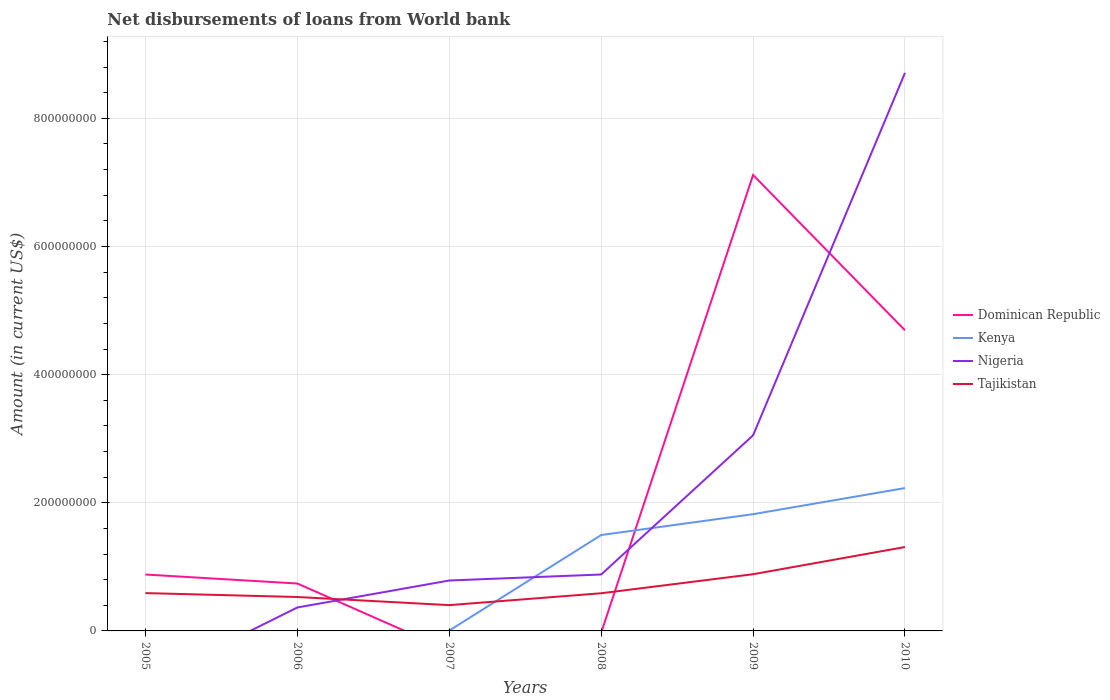How many different coloured lines are there?
Ensure brevity in your answer.  4. Is the number of lines equal to the number of legend labels?
Your answer should be very brief. No. Across all years, what is the maximum amount of loan disbursed from World Bank in Tajikistan?
Offer a very short reply. 4.03e+07. What is the total amount of loan disbursed from World Bank in Tajikistan in the graph?
Provide a succinct answer. -2.97e+07. What is the difference between the highest and the second highest amount of loan disbursed from World Bank in Dominican Republic?
Offer a terse response. 7.12e+08. What is the difference between the highest and the lowest amount of loan disbursed from World Bank in Nigeria?
Offer a very short reply. 2. How many lines are there?
Ensure brevity in your answer.  4. How many years are there in the graph?
Your answer should be compact. 6. What is the difference between two consecutive major ticks on the Y-axis?
Ensure brevity in your answer.  2.00e+08. Where does the legend appear in the graph?
Your response must be concise. Center right. How many legend labels are there?
Offer a very short reply. 4. What is the title of the graph?
Keep it short and to the point. Net disbursements of loans from World bank. What is the label or title of the X-axis?
Provide a succinct answer. Years. What is the Amount (in current US$) in Dominican Republic in 2005?
Keep it short and to the point. 8.80e+07. What is the Amount (in current US$) of Nigeria in 2005?
Make the answer very short. 0. What is the Amount (in current US$) of Tajikistan in 2005?
Your answer should be compact. 5.90e+07. What is the Amount (in current US$) of Dominican Republic in 2006?
Provide a succinct answer. 7.40e+07. What is the Amount (in current US$) in Kenya in 2006?
Your answer should be very brief. 0. What is the Amount (in current US$) in Nigeria in 2006?
Offer a terse response. 3.66e+07. What is the Amount (in current US$) of Tajikistan in 2006?
Give a very brief answer. 5.29e+07. What is the Amount (in current US$) in Dominican Republic in 2007?
Provide a succinct answer. 0. What is the Amount (in current US$) in Kenya in 2007?
Ensure brevity in your answer.  5.68e+05. What is the Amount (in current US$) in Nigeria in 2007?
Make the answer very short. 7.87e+07. What is the Amount (in current US$) in Tajikistan in 2007?
Your answer should be very brief. 4.03e+07. What is the Amount (in current US$) in Kenya in 2008?
Make the answer very short. 1.50e+08. What is the Amount (in current US$) in Nigeria in 2008?
Your answer should be very brief. 8.80e+07. What is the Amount (in current US$) in Tajikistan in 2008?
Keep it short and to the point. 5.88e+07. What is the Amount (in current US$) in Dominican Republic in 2009?
Keep it short and to the point. 7.12e+08. What is the Amount (in current US$) in Kenya in 2009?
Your answer should be compact. 1.82e+08. What is the Amount (in current US$) of Nigeria in 2009?
Your answer should be very brief. 3.05e+08. What is the Amount (in current US$) of Tajikistan in 2009?
Provide a short and direct response. 8.85e+07. What is the Amount (in current US$) in Dominican Republic in 2010?
Your answer should be compact. 4.69e+08. What is the Amount (in current US$) of Kenya in 2010?
Make the answer very short. 2.23e+08. What is the Amount (in current US$) in Nigeria in 2010?
Your answer should be compact. 8.71e+08. What is the Amount (in current US$) of Tajikistan in 2010?
Keep it short and to the point. 1.31e+08. Across all years, what is the maximum Amount (in current US$) in Dominican Republic?
Give a very brief answer. 7.12e+08. Across all years, what is the maximum Amount (in current US$) of Kenya?
Offer a very short reply. 2.23e+08. Across all years, what is the maximum Amount (in current US$) in Nigeria?
Provide a succinct answer. 8.71e+08. Across all years, what is the maximum Amount (in current US$) of Tajikistan?
Your answer should be compact. 1.31e+08. Across all years, what is the minimum Amount (in current US$) of Dominican Republic?
Your answer should be compact. 0. Across all years, what is the minimum Amount (in current US$) in Nigeria?
Ensure brevity in your answer.  0. Across all years, what is the minimum Amount (in current US$) of Tajikistan?
Ensure brevity in your answer.  4.03e+07. What is the total Amount (in current US$) of Dominican Republic in the graph?
Offer a terse response. 1.34e+09. What is the total Amount (in current US$) in Kenya in the graph?
Your answer should be very brief. 5.55e+08. What is the total Amount (in current US$) in Nigeria in the graph?
Provide a short and direct response. 1.38e+09. What is the total Amount (in current US$) in Tajikistan in the graph?
Provide a succinct answer. 4.30e+08. What is the difference between the Amount (in current US$) in Dominican Republic in 2005 and that in 2006?
Keep it short and to the point. 1.40e+07. What is the difference between the Amount (in current US$) in Tajikistan in 2005 and that in 2006?
Provide a short and direct response. 6.09e+06. What is the difference between the Amount (in current US$) of Tajikistan in 2005 and that in 2007?
Give a very brief answer. 1.88e+07. What is the difference between the Amount (in current US$) of Tajikistan in 2005 and that in 2008?
Ensure brevity in your answer.  2.54e+05. What is the difference between the Amount (in current US$) in Dominican Republic in 2005 and that in 2009?
Give a very brief answer. -6.24e+08. What is the difference between the Amount (in current US$) in Tajikistan in 2005 and that in 2009?
Provide a succinct answer. -2.95e+07. What is the difference between the Amount (in current US$) of Dominican Republic in 2005 and that in 2010?
Ensure brevity in your answer.  -3.81e+08. What is the difference between the Amount (in current US$) in Tajikistan in 2005 and that in 2010?
Make the answer very short. -7.19e+07. What is the difference between the Amount (in current US$) in Nigeria in 2006 and that in 2007?
Your answer should be compact. -4.21e+07. What is the difference between the Amount (in current US$) in Tajikistan in 2006 and that in 2007?
Provide a succinct answer. 1.27e+07. What is the difference between the Amount (in current US$) of Nigeria in 2006 and that in 2008?
Provide a succinct answer. -5.14e+07. What is the difference between the Amount (in current US$) in Tajikistan in 2006 and that in 2008?
Offer a terse response. -5.84e+06. What is the difference between the Amount (in current US$) in Dominican Republic in 2006 and that in 2009?
Offer a terse response. -6.38e+08. What is the difference between the Amount (in current US$) in Nigeria in 2006 and that in 2009?
Your answer should be compact. -2.69e+08. What is the difference between the Amount (in current US$) in Tajikistan in 2006 and that in 2009?
Give a very brief answer. -3.56e+07. What is the difference between the Amount (in current US$) in Dominican Republic in 2006 and that in 2010?
Provide a succinct answer. -3.95e+08. What is the difference between the Amount (in current US$) in Nigeria in 2006 and that in 2010?
Keep it short and to the point. -8.34e+08. What is the difference between the Amount (in current US$) of Tajikistan in 2006 and that in 2010?
Provide a short and direct response. -7.80e+07. What is the difference between the Amount (in current US$) in Kenya in 2007 and that in 2008?
Your response must be concise. -1.49e+08. What is the difference between the Amount (in current US$) in Nigeria in 2007 and that in 2008?
Ensure brevity in your answer.  -9.36e+06. What is the difference between the Amount (in current US$) of Tajikistan in 2007 and that in 2008?
Provide a succinct answer. -1.85e+07. What is the difference between the Amount (in current US$) of Kenya in 2007 and that in 2009?
Provide a short and direct response. -1.82e+08. What is the difference between the Amount (in current US$) in Nigeria in 2007 and that in 2009?
Your answer should be very brief. -2.27e+08. What is the difference between the Amount (in current US$) in Tajikistan in 2007 and that in 2009?
Provide a short and direct response. -4.82e+07. What is the difference between the Amount (in current US$) of Kenya in 2007 and that in 2010?
Provide a short and direct response. -2.22e+08. What is the difference between the Amount (in current US$) of Nigeria in 2007 and that in 2010?
Keep it short and to the point. -7.92e+08. What is the difference between the Amount (in current US$) of Tajikistan in 2007 and that in 2010?
Offer a terse response. -9.07e+07. What is the difference between the Amount (in current US$) in Kenya in 2008 and that in 2009?
Your answer should be compact. -3.25e+07. What is the difference between the Amount (in current US$) of Nigeria in 2008 and that in 2009?
Your response must be concise. -2.17e+08. What is the difference between the Amount (in current US$) in Tajikistan in 2008 and that in 2009?
Your answer should be very brief. -2.97e+07. What is the difference between the Amount (in current US$) in Kenya in 2008 and that in 2010?
Provide a short and direct response. -7.33e+07. What is the difference between the Amount (in current US$) of Nigeria in 2008 and that in 2010?
Ensure brevity in your answer.  -7.83e+08. What is the difference between the Amount (in current US$) of Tajikistan in 2008 and that in 2010?
Make the answer very short. -7.22e+07. What is the difference between the Amount (in current US$) in Dominican Republic in 2009 and that in 2010?
Provide a succinct answer. 2.42e+08. What is the difference between the Amount (in current US$) of Kenya in 2009 and that in 2010?
Offer a terse response. -4.08e+07. What is the difference between the Amount (in current US$) of Nigeria in 2009 and that in 2010?
Your answer should be very brief. -5.66e+08. What is the difference between the Amount (in current US$) of Tajikistan in 2009 and that in 2010?
Your response must be concise. -4.24e+07. What is the difference between the Amount (in current US$) in Dominican Republic in 2005 and the Amount (in current US$) in Nigeria in 2006?
Offer a terse response. 5.14e+07. What is the difference between the Amount (in current US$) of Dominican Republic in 2005 and the Amount (in current US$) of Tajikistan in 2006?
Offer a very short reply. 3.51e+07. What is the difference between the Amount (in current US$) of Dominican Republic in 2005 and the Amount (in current US$) of Kenya in 2007?
Offer a terse response. 8.74e+07. What is the difference between the Amount (in current US$) in Dominican Republic in 2005 and the Amount (in current US$) in Nigeria in 2007?
Offer a very short reply. 9.33e+06. What is the difference between the Amount (in current US$) in Dominican Republic in 2005 and the Amount (in current US$) in Tajikistan in 2007?
Your answer should be very brief. 4.77e+07. What is the difference between the Amount (in current US$) in Dominican Republic in 2005 and the Amount (in current US$) in Kenya in 2008?
Offer a very short reply. -6.17e+07. What is the difference between the Amount (in current US$) of Dominican Republic in 2005 and the Amount (in current US$) of Nigeria in 2008?
Make the answer very short. -3.40e+04. What is the difference between the Amount (in current US$) of Dominican Republic in 2005 and the Amount (in current US$) of Tajikistan in 2008?
Offer a very short reply. 2.92e+07. What is the difference between the Amount (in current US$) in Dominican Republic in 2005 and the Amount (in current US$) in Kenya in 2009?
Keep it short and to the point. -9.42e+07. What is the difference between the Amount (in current US$) of Dominican Republic in 2005 and the Amount (in current US$) of Nigeria in 2009?
Provide a short and direct response. -2.17e+08. What is the difference between the Amount (in current US$) of Dominican Republic in 2005 and the Amount (in current US$) of Tajikistan in 2009?
Ensure brevity in your answer.  -4.91e+05. What is the difference between the Amount (in current US$) in Dominican Republic in 2005 and the Amount (in current US$) in Kenya in 2010?
Your response must be concise. -1.35e+08. What is the difference between the Amount (in current US$) of Dominican Republic in 2005 and the Amount (in current US$) of Nigeria in 2010?
Offer a terse response. -7.83e+08. What is the difference between the Amount (in current US$) in Dominican Republic in 2005 and the Amount (in current US$) in Tajikistan in 2010?
Ensure brevity in your answer.  -4.29e+07. What is the difference between the Amount (in current US$) in Dominican Republic in 2006 and the Amount (in current US$) in Kenya in 2007?
Make the answer very short. 7.34e+07. What is the difference between the Amount (in current US$) of Dominican Republic in 2006 and the Amount (in current US$) of Nigeria in 2007?
Your answer should be very brief. -4.69e+06. What is the difference between the Amount (in current US$) in Dominican Republic in 2006 and the Amount (in current US$) in Tajikistan in 2007?
Ensure brevity in your answer.  3.37e+07. What is the difference between the Amount (in current US$) in Nigeria in 2006 and the Amount (in current US$) in Tajikistan in 2007?
Keep it short and to the point. -3.66e+06. What is the difference between the Amount (in current US$) in Dominican Republic in 2006 and the Amount (in current US$) in Kenya in 2008?
Keep it short and to the point. -7.57e+07. What is the difference between the Amount (in current US$) of Dominican Republic in 2006 and the Amount (in current US$) of Nigeria in 2008?
Make the answer very short. -1.41e+07. What is the difference between the Amount (in current US$) of Dominican Republic in 2006 and the Amount (in current US$) of Tajikistan in 2008?
Your answer should be very brief. 1.52e+07. What is the difference between the Amount (in current US$) in Nigeria in 2006 and the Amount (in current US$) in Tajikistan in 2008?
Give a very brief answer. -2.22e+07. What is the difference between the Amount (in current US$) of Dominican Republic in 2006 and the Amount (in current US$) of Kenya in 2009?
Keep it short and to the point. -1.08e+08. What is the difference between the Amount (in current US$) of Dominican Republic in 2006 and the Amount (in current US$) of Nigeria in 2009?
Your answer should be compact. -2.31e+08. What is the difference between the Amount (in current US$) in Dominican Republic in 2006 and the Amount (in current US$) in Tajikistan in 2009?
Offer a very short reply. -1.45e+07. What is the difference between the Amount (in current US$) of Nigeria in 2006 and the Amount (in current US$) of Tajikistan in 2009?
Give a very brief answer. -5.19e+07. What is the difference between the Amount (in current US$) in Dominican Republic in 2006 and the Amount (in current US$) in Kenya in 2010?
Offer a terse response. -1.49e+08. What is the difference between the Amount (in current US$) in Dominican Republic in 2006 and the Amount (in current US$) in Nigeria in 2010?
Your answer should be very brief. -7.97e+08. What is the difference between the Amount (in current US$) of Dominican Republic in 2006 and the Amount (in current US$) of Tajikistan in 2010?
Make the answer very short. -5.69e+07. What is the difference between the Amount (in current US$) in Nigeria in 2006 and the Amount (in current US$) in Tajikistan in 2010?
Offer a terse response. -9.43e+07. What is the difference between the Amount (in current US$) in Kenya in 2007 and the Amount (in current US$) in Nigeria in 2008?
Keep it short and to the point. -8.75e+07. What is the difference between the Amount (in current US$) of Kenya in 2007 and the Amount (in current US$) of Tajikistan in 2008?
Provide a short and direct response. -5.82e+07. What is the difference between the Amount (in current US$) of Nigeria in 2007 and the Amount (in current US$) of Tajikistan in 2008?
Make the answer very short. 1.99e+07. What is the difference between the Amount (in current US$) of Kenya in 2007 and the Amount (in current US$) of Nigeria in 2009?
Give a very brief answer. -3.05e+08. What is the difference between the Amount (in current US$) in Kenya in 2007 and the Amount (in current US$) in Tajikistan in 2009?
Provide a short and direct response. -8.79e+07. What is the difference between the Amount (in current US$) in Nigeria in 2007 and the Amount (in current US$) in Tajikistan in 2009?
Give a very brief answer. -9.82e+06. What is the difference between the Amount (in current US$) of Kenya in 2007 and the Amount (in current US$) of Nigeria in 2010?
Keep it short and to the point. -8.70e+08. What is the difference between the Amount (in current US$) in Kenya in 2007 and the Amount (in current US$) in Tajikistan in 2010?
Give a very brief answer. -1.30e+08. What is the difference between the Amount (in current US$) of Nigeria in 2007 and the Amount (in current US$) of Tajikistan in 2010?
Give a very brief answer. -5.23e+07. What is the difference between the Amount (in current US$) of Kenya in 2008 and the Amount (in current US$) of Nigeria in 2009?
Your answer should be compact. -1.56e+08. What is the difference between the Amount (in current US$) of Kenya in 2008 and the Amount (in current US$) of Tajikistan in 2009?
Offer a very short reply. 6.12e+07. What is the difference between the Amount (in current US$) in Nigeria in 2008 and the Amount (in current US$) in Tajikistan in 2009?
Make the answer very short. -4.57e+05. What is the difference between the Amount (in current US$) of Kenya in 2008 and the Amount (in current US$) of Nigeria in 2010?
Your answer should be compact. -7.21e+08. What is the difference between the Amount (in current US$) in Kenya in 2008 and the Amount (in current US$) in Tajikistan in 2010?
Offer a terse response. 1.87e+07. What is the difference between the Amount (in current US$) of Nigeria in 2008 and the Amount (in current US$) of Tajikistan in 2010?
Provide a succinct answer. -4.29e+07. What is the difference between the Amount (in current US$) in Dominican Republic in 2009 and the Amount (in current US$) in Kenya in 2010?
Ensure brevity in your answer.  4.89e+08. What is the difference between the Amount (in current US$) in Dominican Republic in 2009 and the Amount (in current US$) in Nigeria in 2010?
Your response must be concise. -1.59e+08. What is the difference between the Amount (in current US$) in Dominican Republic in 2009 and the Amount (in current US$) in Tajikistan in 2010?
Make the answer very short. 5.81e+08. What is the difference between the Amount (in current US$) in Kenya in 2009 and the Amount (in current US$) in Nigeria in 2010?
Your answer should be very brief. -6.89e+08. What is the difference between the Amount (in current US$) in Kenya in 2009 and the Amount (in current US$) in Tajikistan in 2010?
Keep it short and to the point. 5.12e+07. What is the difference between the Amount (in current US$) of Nigeria in 2009 and the Amount (in current US$) of Tajikistan in 2010?
Give a very brief answer. 1.74e+08. What is the average Amount (in current US$) of Dominican Republic per year?
Your response must be concise. 2.24e+08. What is the average Amount (in current US$) in Kenya per year?
Keep it short and to the point. 9.26e+07. What is the average Amount (in current US$) in Nigeria per year?
Your answer should be very brief. 2.30e+08. What is the average Amount (in current US$) in Tajikistan per year?
Your answer should be very brief. 7.17e+07. In the year 2005, what is the difference between the Amount (in current US$) in Dominican Republic and Amount (in current US$) in Tajikistan?
Keep it short and to the point. 2.90e+07. In the year 2006, what is the difference between the Amount (in current US$) of Dominican Republic and Amount (in current US$) of Nigeria?
Ensure brevity in your answer.  3.74e+07. In the year 2006, what is the difference between the Amount (in current US$) in Dominican Republic and Amount (in current US$) in Tajikistan?
Your response must be concise. 2.11e+07. In the year 2006, what is the difference between the Amount (in current US$) in Nigeria and Amount (in current US$) in Tajikistan?
Keep it short and to the point. -1.63e+07. In the year 2007, what is the difference between the Amount (in current US$) of Kenya and Amount (in current US$) of Nigeria?
Offer a terse response. -7.81e+07. In the year 2007, what is the difference between the Amount (in current US$) in Kenya and Amount (in current US$) in Tajikistan?
Ensure brevity in your answer.  -3.97e+07. In the year 2007, what is the difference between the Amount (in current US$) in Nigeria and Amount (in current US$) in Tajikistan?
Your answer should be compact. 3.84e+07. In the year 2008, what is the difference between the Amount (in current US$) of Kenya and Amount (in current US$) of Nigeria?
Provide a short and direct response. 6.16e+07. In the year 2008, what is the difference between the Amount (in current US$) of Kenya and Amount (in current US$) of Tajikistan?
Your response must be concise. 9.09e+07. In the year 2008, what is the difference between the Amount (in current US$) in Nigeria and Amount (in current US$) in Tajikistan?
Offer a very short reply. 2.93e+07. In the year 2009, what is the difference between the Amount (in current US$) in Dominican Republic and Amount (in current US$) in Kenya?
Offer a very short reply. 5.29e+08. In the year 2009, what is the difference between the Amount (in current US$) in Dominican Republic and Amount (in current US$) in Nigeria?
Make the answer very short. 4.06e+08. In the year 2009, what is the difference between the Amount (in current US$) of Dominican Republic and Amount (in current US$) of Tajikistan?
Offer a very short reply. 6.23e+08. In the year 2009, what is the difference between the Amount (in current US$) in Kenya and Amount (in current US$) in Nigeria?
Make the answer very short. -1.23e+08. In the year 2009, what is the difference between the Amount (in current US$) of Kenya and Amount (in current US$) of Tajikistan?
Your answer should be compact. 9.37e+07. In the year 2009, what is the difference between the Amount (in current US$) in Nigeria and Amount (in current US$) in Tajikistan?
Provide a succinct answer. 2.17e+08. In the year 2010, what is the difference between the Amount (in current US$) of Dominican Republic and Amount (in current US$) of Kenya?
Ensure brevity in your answer.  2.46e+08. In the year 2010, what is the difference between the Amount (in current US$) of Dominican Republic and Amount (in current US$) of Nigeria?
Offer a terse response. -4.02e+08. In the year 2010, what is the difference between the Amount (in current US$) of Dominican Republic and Amount (in current US$) of Tajikistan?
Keep it short and to the point. 3.38e+08. In the year 2010, what is the difference between the Amount (in current US$) in Kenya and Amount (in current US$) in Nigeria?
Provide a short and direct response. -6.48e+08. In the year 2010, what is the difference between the Amount (in current US$) in Kenya and Amount (in current US$) in Tajikistan?
Offer a very short reply. 9.20e+07. In the year 2010, what is the difference between the Amount (in current US$) of Nigeria and Amount (in current US$) of Tajikistan?
Ensure brevity in your answer.  7.40e+08. What is the ratio of the Amount (in current US$) of Dominican Republic in 2005 to that in 2006?
Offer a terse response. 1.19. What is the ratio of the Amount (in current US$) of Tajikistan in 2005 to that in 2006?
Your answer should be very brief. 1.11. What is the ratio of the Amount (in current US$) in Tajikistan in 2005 to that in 2007?
Provide a short and direct response. 1.47. What is the ratio of the Amount (in current US$) of Dominican Republic in 2005 to that in 2009?
Ensure brevity in your answer.  0.12. What is the ratio of the Amount (in current US$) in Tajikistan in 2005 to that in 2009?
Offer a terse response. 0.67. What is the ratio of the Amount (in current US$) in Dominican Republic in 2005 to that in 2010?
Give a very brief answer. 0.19. What is the ratio of the Amount (in current US$) in Tajikistan in 2005 to that in 2010?
Ensure brevity in your answer.  0.45. What is the ratio of the Amount (in current US$) in Nigeria in 2006 to that in 2007?
Give a very brief answer. 0.47. What is the ratio of the Amount (in current US$) in Tajikistan in 2006 to that in 2007?
Offer a terse response. 1.31. What is the ratio of the Amount (in current US$) in Nigeria in 2006 to that in 2008?
Offer a terse response. 0.42. What is the ratio of the Amount (in current US$) of Tajikistan in 2006 to that in 2008?
Ensure brevity in your answer.  0.9. What is the ratio of the Amount (in current US$) of Dominican Republic in 2006 to that in 2009?
Give a very brief answer. 0.1. What is the ratio of the Amount (in current US$) in Nigeria in 2006 to that in 2009?
Offer a very short reply. 0.12. What is the ratio of the Amount (in current US$) of Tajikistan in 2006 to that in 2009?
Keep it short and to the point. 0.6. What is the ratio of the Amount (in current US$) of Dominican Republic in 2006 to that in 2010?
Offer a terse response. 0.16. What is the ratio of the Amount (in current US$) in Nigeria in 2006 to that in 2010?
Offer a terse response. 0.04. What is the ratio of the Amount (in current US$) in Tajikistan in 2006 to that in 2010?
Provide a succinct answer. 0.4. What is the ratio of the Amount (in current US$) in Kenya in 2007 to that in 2008?
Provide a short and direct response. 0. What is the ratio of the Amount (in current US$) in Nigeria in 2007 to that in 2008?
Ensure brevity in your answer.  0.89. What is the ratio of the Amount (in current US$) in Tajikistan in 2007 to that in 2008?
Your response must be concise. 0.69. What is the ratio of the Amount (in current US$) of Kenya in 2007 to that in 2009?
Provide a short and direct response. 0. What is the ratio of the Amount (in current US$) of Nigeria in 2007 to that in 2009?
Your answer should be compact. 0.26. What is the ratio of the Amount (in current US$) in Tajikistan in 2007 to that in 2009?
Your response must be concise. 0.46. What is the ratio of the Amount (in current US$) of Kenya in 2007 to that in 2010?
Ensure brevity in your answer.  0. What is the ratio of the Amount (in current US$) in Nigeria in 2007 to that in 2010?
Offer a very short reply. 0.09. What is the ratio of the Amount (in current US$) in Tajikistan in 2007 to that in 2010?
Your answer should be very brief. 0.31. What is the ratio of the Amount (in current US$) of Kenya in 2008 to that in 2009?
Keep it short and to the point. 0.82. What is the ratio of the Amount (in current US$) of Nigeria in 2008 to that in 2009?
Your answer should be very brief. 0.29. What is the ratio of the Amount (in current US$) of Tajikistan in 2008 to that in 2009?
Provide a short and direct response. 0.66. What is the ratio of the Amount (in current US$) of Kenya in 2008 to that in 2010?
Provide a short and direct response. 0.67. What is the ratio of the Amount (in current US$) in Nigeria in 2008 to that in 2010?
Your answer should be compact. 0.1. What is the ratio of the Amount (in current US$) of Tajikistan in 2008 to that in 2010?
Offer a terse response. 0.45. What is the ratio of the Amount (in current US$) in Dominican Republic in 2009 to that in 2010?
Your answer should be very brief. 1.52. What is the ratio of the Amount (in current US$) in Kenya in 2009 to that in 2010?
Keep it short and to the point. 0.82. What is the ratio of the Amount (in current US$) of Nigeria in 2009 to that in 2010?
Your response must be concise. 0.35. What is the ratio of the Amount (in current US$) of Tajikistan in 2009 to that in 2010?
Give a very brief answer. 0.68. What is the difference between the highest and the second highest Amount (in current US$) of Dominican Republic?
Your answer should be very brief. 2.42e+08. What is the difference between the highest and the second highest Amount (in current US$) of Kenya?
Keep it short and to the point. 4.08e+07. What is the difference between the highest and the second highest Amount (in current US$) of Nigeria?
Your answer should be very brief. 5.66e+08. What is the difference between the highest and the second highest Amount (in current US$) of Tajikistan?
Offer a very short reply. 4.24e+07. What is the difference between the highest and the lowest Amount (in current US$) in Dominican Republic?
Offer a very short reply. 7.12e+08. What is the difference between the highest and the lowest Amount (in current US$) of Kenya?
Offer a very short reply. 2.23e+08. What is the difference between the highest and the lowest Amount (in current US$) of Nigeria?
Make the answer very short. 8.71e+08. What is the difference between the highest and the lowest Amount (in current US$) of Tajikistan?
Your answer should be compact. 9.07e+07. 